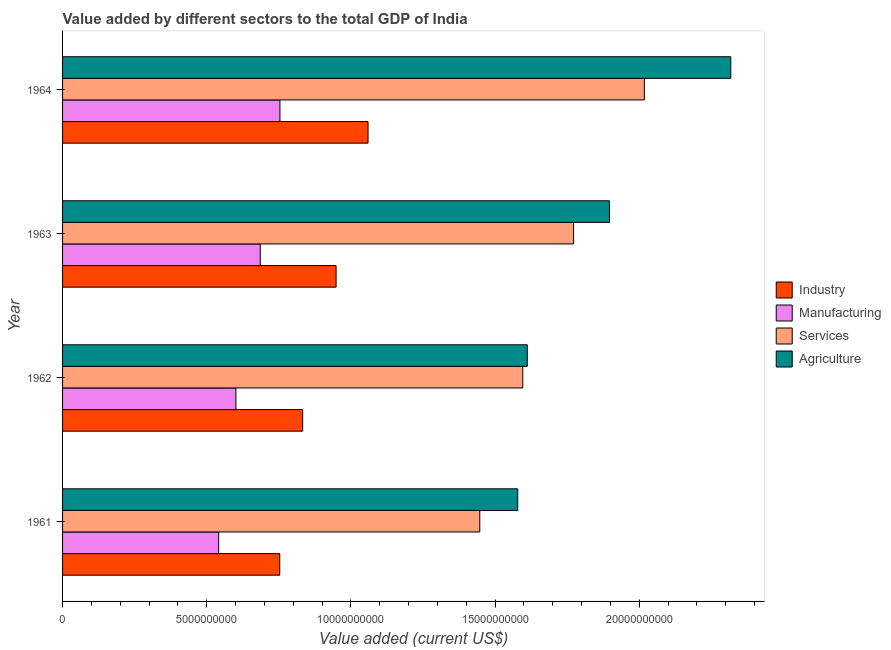How many different coloured bars are there?
Provide a short and direct response. 4. Are the number of bars on each tick of the Y-axis equal?
Offer a terse response. Yes. How many bars are there on the 4th tick from the top?
Your answer should be compact. 4. What is the label of the 3rd group of bars from the top?
Provide a short and direct response. 1962. What is the value added by industrial sector in 1964?
Your response must be concise. 1.06e+1. Across all years, what is the maximum value added by agricultural sector?
Your answer should be compact. 2.32e+1. Across all years, what is the minimum value added by agricultural sector?
Your answer should be compact. 1.58e+1. In which year was the value added by services sector maximum?
Make the answer very short. 1964. What is the total value added by manufacturing sector in the graph?
Offer a very short reply. 2.58e+1. What is the difference between the value added by manufacturing sector in 1962 and that in 1964?
Provide a succinct answer. -1.53e+09. What is the difference between the value added by agricultural sector in 1963 and the value added by services sector in 1964?
Your response must be concise. -1.21e+09. What is the average value added by manufacturing sector per year?
Provide a succinct answer. 6.45e+09. In the year 1962, what is the difference between the value added by manufacturing sector and value added by services sector?
Offer a very short reply. -9.95e+09. What is the ratio of the value added by agricultural sector in 1963 to that in 1964?
Offer a very short reply. 0.82. What is the difference between the highest and the second highest value added by agricultural sector?
Give a very brief answer. 4.21e+09. What is the difference between the highest and the lowest value added by agricultural sector?
Provide a short and direct response. 7.39e+09. Is the sum of the value added by industrial sector in 1962 and 1963 greater than the maximum value added by manufacturing sector across all years?
Your answer should be very brief. Yes. Is it the case that in every year, the sum of the value added by manufacturing sector and value added by agricultural sector is greater than the sum of value added by services sector and value added by industrial sector?
Offer a terse response. Yes. What does the 2nd bar from the top in 1962 represents?
Provide a short and direct response. Services. What does the 1st bar from the bottom in 1961 represents?
Offer a very short reply. Industry. Is it the case that in every year, the sum of the value added by industrial sector and value added by manufacturing sector is greater than the value added by services sector?
Your response must be concise. No. How many years are there in the graph?
Offer a very short reply. 4. What is the difference between two consecutive major ticks on the X-axis?
Make the answer very short. 5.00e+09. Does the graph contain grids?
Offer a very short reply. No. Where does the legend appear in the graph?
Give a very brief answer. Center right. How many legend labels are there?
Offer a terse response. 4. What is the title of the graph?
Your response must be concise. Value added by different sectors to the total GDP of India. Does "Primary schools" appear as one of the legend labels in the graph?
Your answer should be very brief. No. What is the label or title of the X-axis?
Your response must be concise. Value added (current US$). What is the label or title of the Y-axis?
Make the answer very short. Year. What is the Value added (current US$) of Industry in 1961?
Provide a succinct answer. 7.53e+09. What is the Value added (current US$) of Manufacturing in 1961?
Provide a short and direct response. 5.41e+09. What is the Value added (current US$) in Services in 1961?
Provide a succinct answer. 1.45e+1. What is the Value added (current US$) of Agriculture in 1961?
Ensure brevity in your answer.  1.58e+1. What is the Value added (current US$) of Industry in 1962?
Offer a terse response. 8.33e+09. What is the Value added (current US$) in Manufacturing in 1962?
Give a very brief answer. 6.01e+09. What is the Value added (current US$) of Services in 1962?
Give a very brief answer. 1.60e+1. What is the Value added (current US$) of Agriculture in 1962?
Offer a very short reply. 1.61e+1. What is the Value added (current US$) in Industry in 1963?
Your response must be concise. 9.49e+09. What is the Value added (current US$) in Manufacturing in 1963?
Your response must be concise. 6.85e+09. What is the Value added (current US$) in Services in 1963?
Your answer should be compact. 1.77e+1. What is the Value added (current US$) in Agriculture in 1963?
Your response must be concise. 1.90e+1. What is the Value added (current US$) of Industry in 1964?
Your answer should be very brief. 1.06e+1. What is the Value added (current US$) of Manufacturing in 1964?
Keep it short and to the point. 7.54e+09. What is the Value added (current US$) in Services in 1964?
Ensure brevity in your answer.  2.02e+1. What is the Value added (current US$) of Agriculture in 1964?
Your answer should be very brief. 2.32e+1. Across all years, what is the maximum Value added (current US$) of Industry?
Give a very brief answer. 1.06e+1. Across all years, what is the maximum Value added (current US$) in Manufacturing?
Offer a terse response. 7.54e+09. Across all years, what is the maximum Value added (current US$) in Services?
Your answer should be very brief. 2.02e+1. Across all years, what is the maximum Value added (current US$) in Agriculture?
Offer a terse response. 2.32e+1. Across all years, what is the minimum Value added (current US$) of Industry?
Your answer should be compact. 7.53e+09. Across all years, what is the minimum Value added (current US$) of Manufacturing?
Provide a succinct answer. 5.41e+09. Across all years, what is the minimum Value added (current US$) in Services?
Ensure brevity in your answer.  1.45e+1. Across all years, what is the minimum Value added (current US$) of Agriculture?
Offer a very short reply. 1.58e+1. What is the total Value added (current US$) of Industry in the graph?
Your response must be concise. 3.59e+1. What is the total Value added (current US$) in Manufacturing in the graph?
Your answer should be compact. 2.58e+1. What is the total Value added (current US$) of Services in the graph?
Offer a very short reply. 6.83e+1. What is the total Value added (current US$) in Agriculture in the graph?
Provide a short and direct response. 7.40e+1. What is the difference between the Value added (current US$) of Industry in 1961 and that in 1962?
Give a very brief answer. -7.94e+08. What is the difference between the Value added (current US$) of Manufacturing in 1961 and that in 1962?
Offer a terse response. -5.97e+08. What is the difference between the Value added (current US$) of Services in 1961 and that in 1962?
Your answer should be very brief. -1.49e+09. What is the difference between the Value added (current US$) of Agriculture in 1961 and that in 1962?
Provide a succinct answer. -3.32e+08. What is the difference between the Value added (current US$) of Industry in 1961 and that in 1963?
Offer a very short reply. -1.95e+09. What is the difference between the Value added (current US$) in Manufacturing in 1961 and that in 1963?
Provide a succinct answer. -1.44e+09. What is the difference between the Value added (current US$) of Services in 1961 and that in 1963?
Give a very brief answer. -3.25e+09. What is the difference between the Value added (current US$) in Agriculture in 1961 and that in 1963?
Make the answer very short. -3.18e+09. What is the difference between the Value added (current US$) in Industry in 1961 and that in 1964?
Provide a short and direct response. -3.06e+09. What is the difference between the Value added (current US$) of Manufacturing in 1961 and that in 1964?
Your answer should be compact. -2.12e+09. What is the difference between the Value added (current US$) of Services in 1961 and that in 1964?
Provide a short and direct response. -5.71e+09. What is the difference between the Value added (current US$) in Agriculture in 1961 and that in 1964?
Give a very brief answer. -7.39e+09. What is the difference between the Value added (current US$) of Industry in 1962 and that in 1963?
Your answer should be compact. -1.16e+09. What is the difference between the Value added (current US$) of Manufacturing in 1962 and that in 1963?
Keep it short and to the point. -8.44e+08. What is the difference between the Value added (current US$) in Services in 1962 and that in 1963?
Provide a short and direct response. -1.76e+09. What is the difference between the Value added (current US$) in Agriculture in 1962 and that in 1963?
Your response must be concise. -2.85e+09. What is the difference between the Value added (current US$) in Industry in 1962 and that in 1964?
Keep it short and to the point. -2.27e+09. What is the difference between the Value added (current US$) of Manufacturing in 1962 and that in 1964?
Provide a short and direct response. -1.53e+09. What is the difference between the Value added (current US$) of Services in 1962 and that in 1964?
Ensure brevity in your answer.  -4.22e+09. What is the difference between the Value added (current US$) of Agriculture in 1962 and that in 1964?
Make the answer very short. -7.06e+09. What is the difference between the Value added (current US$) of Industry in 1963 and that in 1964?
Give a very brief answer. -1.11e+09. What is the difference between the Value added (current US$) of Manufacturing in 1963 and that in 1964?
Your answer should be compact. -6.83e+08. What is the difference between the Value added (current US$) in Services in 1963 and that in 1964?
Your response must be concise. -2.45e+09. What is the difference between the Value added (current US$) in Agriculture in 1963 and that in 1964?
Provide a succinct answer. -4.21e+09. What is the difference between the Value added (current US$) of Industry in 1961 and the Value added (current US$) of Manufacturing in 1962?
Keep it short and to the point. 1.52e+09. What is the difference between the Value added (current US$) in Industry in 1961 and the Value added (current US$) in Services in 1962?
Make the answer very short. -8.43e+09. What is the difference between the Value added (current US$) in Industry in 1961 and the Value added (current US$) in Agriculture in 1962?
Your response must be concise. -8.58e+09. What is the difference between the Value added (current US$) of Manufacturing in 1961 and the Value added (current US$) of Services in 1962?
Make the answer very short. -1.05e+1. What is the difference between the Value added (current US$) in Manufacturing in 1961 and the Value added (current US$) in Agriculture in 1962?
Make the answer very short. -1.07e+1. What is the difference between the Value added (current US$) in Services in 1961 and the Value added (current US$) in Agriculture in 1962?
Give a very brief answer. -1.65e+09. What is the difference between the Value added (current US$) of Industry in 1961 and the Value added (current US$) of Manufacturing in 1963?
Offer a terse response. 6.76e+08. What is the difference between the Value added (current US$) of Industry in 1961 and the Value added (current US$) of Services in 1963?
Your answer should be compact. -1.02e+1. What is the difference between the Value added (current US$) of Industry in 1961 and the Value added (current US$) of Agriculture in 1963?
Provide a succinct answer. -1.14e+1. What is the difference between the Value added (current US$) of Manufacturing in 1961 and the Value added (current US$) of Services in 1963?
Make the answer very short. -1.23e+1. What is the difference between the Value added (current US$) of Manufacturing in 1961 and the Value added (current US$) of Agriculture in 1963?
Ensure brevity in your answer.  -1.36e+1. What is the difference between the Value added (current US$) in Services in 1961 and the Value added (current US$) in Agriculture in 1963?
Make the answer very short. -4.50e+09. What is the difference between the Value added (current US$) of Industry in 1961 and the Value added (current US$) of Manufacturing in 1964?
Offer a terse response. -6.79e+06. What is the difference between the Value added (current US$) of Industry in 1961 and the Value added (current US$) of Services in 1964?
Ensure brevity in your answer.  -1.26e+1. What is the difference between the Value added (current US$) in Industry in 1961 and the Value added (current US$) in Agriculture in 1964?
Keep it short and to the point. -1.56e+1. What is the difference between the Value added (current US$) in Manufacturing in 1961 and the Value added (current US$) in Services in 1964?
Offer a terse response. -1.48e+1. What is the difference between the Value added (current US$) in Manufacturing in 1961 and the Value added (current US$) in Agriculture in 1964?
Offer a very short reply. -1.78e+1. What is the difference between the Value added (current US$) of Services in 1961 and the Value added (current US$) of Agriculture in 1964?
Keep it short and to the point. -8.70e+09. What is the difference between the Value added (current US$) in Industry in 1962 and the Value added (current US$) in Manufacturing in 1963?
Make the answer very short. 1.47e+09. What is the difference between the Value added (current US$) of Industry in 1962 and the Value added (current US$) of Services in 1963?
Ensure brevity in your answer.  -9.40e+09. What is the difference between the Value added (current US$) of Industry in 1962 and the Value added (current US$) of Agriculture in 1963?
Your response must be concise. -1.06e+1. What is the difference between the Value added (current US$) in Manufacturing in 1962 and the Value added (current US$) in Services in 1963?
Your answer should be compact. -1.17e+1. What is the difference between the Value added (current US$) in Manufacturing in 1962 and the Value added (current US$) in Agriculture in 1963?
Provide a short and direct response. -1.30e+1. What is the difference between the Value added (current US$) of Services in 1962 and the Value added (current US$) of Agriculture in 1963?
Keep it short and to the point. -3.01e+09. What is the difference between the Value added (current US$) of Industry in 1962 and the Value added (current US$) of Manufacturing in 1964?
Offer a very short reply. 7.88e+08. What is the difference between the Value added (current US$) of Industry in 1962 and the Value added (current US$) of Services in 1964?
Your answer should be compact. -1.18e+1. What is the difference between the Value added (current US$) of Industry in 1962 and the Value added (current US$) of Agriculture in 1964?
Your answer should be very brief. -1.48e+1. What is the difference between the Value added (current US$) in Manufacturing in 1962 and the Value added (current US$) in Services in 1964?
Your answer should be compact. -1.42e+1. What is the difference between the Value added (current US$) in Manufacturing in 1962 and the Value added (current US$) in Agriculture in 1964?
Offer a very short reply. -1.72e+1. What is the difference between the Value added (current US$) of Services in 1962 and the Value added (current US$) of Agriculture in 1964?
Make the answer very short. -7.21e+09. What is the difference between the Value added (current US$) of Industry in 1963 and the Value added (current US$) of Manufacturing in 1964?
Offer a terse response. 1.95e+09. What is the difference between the Value added (current US$) of Industry in 1963 and the Value added (current US$) of Services in 1964?
Make the answer very short. -1.07e+1. What is the difference between the Value added (current US$) in Industry in 1963 and the Value added (current US$) in Agriculture in 1964?
Give a very brief answer. -1.37e+1. What is the difference between the Value added (current US$) of Manufacturing in 1963 and the Value added (current US$) of Services in 1964?
Give a very brief answer. -1.33e+1. What is the difference between the Value added (current US$) in Manufacturing in 1963 and the Value added (current US$) in Agriculture in 1964?
Your answer should be very brief. -1.63e+1. What is the difference between the Value added (current US$) in Services in 1963 and the Value added (current US$) in Agriculture in 1964?
Give a very brief answer. -5.45e+09. What is the average Value added (current US$) of Industry per year?
Ensure brevity in your answer.  8.98e+09. What is the average Value added (current US$) in Manufacturing per year?
Your response must be concise. 6.45e+09. What is the average Value added (current US$) in Services per year?
Your response must be concise. 1.71e+1. What is the average Value added (current US$) of Agriculture per year?
Your answer should be very brief. 1.85e+1. In the year 1961, what is the difference between the Value added (current US$) of Industry and Value added (current US$) of Manufacturing?
Provide a short and direct response. 2.12e+09. In the year 1961, what is the difference between the Value added (current US$) of Industry and Value added (current US$) of Services?
Provide a succinct answer. -6.94e+09. In the year 1961, what is the difference between the Value added (current US$) of Industry and Value added (current US$) of Agriculture?
Give a very brief answer. -8.25e+09. In the year 1961, what is the difference between the Value added (current US$) in Manufacturing and Value added (current US$) in Services?
Offer a terse response. -9.05e+09. In the year 1961, what is the difference between the Value added (current US$) of Manufacturing and Value added (current US$) of Agriculture?
Keep it short and to the point. -1.04e+1. In the year 1961, what is the difference between the Value added (current US$) of Services and Value added (current US$) of Agriculture?
Your answer should be compact. -1.32e+09. In the year 1962, what is the difference between the Value added (current US$) of Industry and Value added (current US$) of Manufacturing?
Your answer should be compact. 2.31e+09. In the year 1962, what is the difference between the Value added (current US$) in Industry and Value added (current US$) in Services?
Your response must be concise. -7.63e+09. In the year 1962, what is the difference between the Value added (current US$) of Industry and Value added (current US$) of Agriculture?
Keep it short and to the point. -7.79e+09. In the year 1962, what is the difference between the Value added (current US$) in Manufacturing and Value added (current US$) in Services?
Your answer should be very brief. -9.95e+09. In the year 1962, what is the difference between the Value added (current US$) of Manufacturing and Value added (current US$) of Agriculture?
Your answer should be very brief. -1.01e+1. In the year 1962, what is the difference between the Value added (current US$) of Services and Value added (current US$) of Agriculture?
Your answer should be very brief. -1.56e+08. In the year 1963, what is the difference between the Value added (current US$) of Industry and Value added (current US$) of Manufacturing?
Your answer should be very brief. 2.63e+09. In the year 1963, what is the difference between the Value added (current US$) of Industry and Value added (current US$) of Services?
Your answer should be very brief. -8.24e+09. In the year 1963, what is the difference between the Value added (current US$) of Industry and Value added (current US$) of Agriculture?
Provide a succinct answer. -9.48e+09. In the year 1963, what is the difference between the Value added (current US$) of Manufacturing and Value added (current US$) of Services?
Your response must be concise. -1.09e+1. In the year 1963, what is the difference between the Value added (current US$) in Manufacturing and Value added (current US$) in Agriculture?
Offer a very short reply. -1.21e+1. In the year 1963, what is the difference between the Value added (current US$) in Services and Value added (current US$) in Agriculture?
Your answer should be compact. -1.24e+09. In the year 1964, what is the difference between the Value added (current US$) in Industry and Value added (current US$) in Manufacturing?
Offer a very short reply. 3.06e+09. In the year 1964, what is the difference between the Value added (current US$) of Industry and Value added (current US$) of Services?
Offer a very short reply. -9.58e+09. In the year 1964, what is the difference between the Value added (current US$) of Industry and Value added (current US$) of Agriculture?
Provide a short and direct response. -1.26e+1. In the year 1964, what is the difference between the Value added (current US$) in Manufacturing and Value added (current US$) in Services?
Your answer should be very brief. -1.26e+1. In the year 1964, what is the difference between the Value added (current US$) in Manufacturing and Value added (current US$) in Agriculture?
Provide a succinct answer. -1.56e+1. In the year 1964, what is the difference between the Value added (current US$) of Services and Value added (current US$) of Agriculture?
Your answer should be compact. -3.00e+09. What is the ratio of the Value added (current US$) in Industry in 1961 to that in 1962?
Your answer should be very brief. 0.9. What is the ratio of the Value added (current US$) in Manufacturing in 1961 to that in 1962?
Provide a succinct answer. 0.9. What is the ratio of the Value added (current US$) in Services in 1961 to that in 1962?
Make the answer very short. 0.91. What is the ratio of the Value added (current US$) of Agriculture in 1961 to that in 1962?
Offer a terse response. 0.98. What is the ratio of the Value added (current US$) in Industry in 1961 to that in 1963?
Your answer should be very brief. 0.79. What is the ratio of the Value added (current US$) of Manufacturing in 1961 to that in 1963?
Your answer should be compact. 0.79. What is the ratio of the Value added (current US$) of Services in 1961 to that in 1963?
Ensure brevity in your answer.  0.82. What is the ratio of the Value added (current US$) in Agriculture in 1961 to that in 1963?
Your response must be concise. 0.83. What is the ratio of the Value added (current US$) in Industry in 1961 to that in 1964?
Your response must be concise. 0.71. What is the ratio of the Value added (current US$) of Manufacturing in 1961 to that in 1964?
Provide a short and direct response. 0.72. What is the ratio of the Value added (current US$) in Services in 1961 to that in 1964?
Offer a very short reply. 0.72. What is the ratio of the Value added (current US$) in Agriculture in 1961 to that in 1964?
Offer a very short reply. 0.68. What is the ratio of the Value added (current US$) in Industry in 1962 to that in 1963?
Provide a succinct answer. 0.88. What is the ratio of the Value added (current US$) in Manufacturing in 1962 to that in 1963?
Keep it short and to the point. 0.88. What is the ratio of the Value added (current US$) in Services in 1962 to that in 1963?
Your answer should be very brief. 0.9. What is the ratio of the Value added (current US$) in Agriculture in 1962 to that in 1963?
Offer a terse response. 0.85. What is the ratio of the Value added (current US$) in Industry in 1962 to that in 1964?
Your response must be concise. 0.79. What is the ratio of the Value added (current US$) in Manufacturing in 1962 to that in 1964?
Your answer should be very brief. 0.8. What is the ratio of the Value added (current US$) in Services in 1962 to that in 1964?
Provide a short and direct response. 0.79. What is the ratio of the Value added (current US$) in Agriculture in 1962 to that in 1964?
Offer a very short reply. 0.7. What is the ratio of the Value added (current US$) in Industry in 1963 to that in 1964?
Your response must be concise. 0.9. What is the ratio of the Value added (current US$) of Manufacturing in 1963 to that in 1964?
Keep it short and to the point. 0.91. What is the ratio of the Value added (current US$) of Services in 1963 to that in 1964?
Offer a terse response. 0.88. What is the ratio of the Value added (current US$) in Agriculture in 1963 to that in 1964?
Provide a succinct answer. 0.82. What is the difference between the highest and the second highest Value added (current US$) of Industry?
Offer a very short reply. 1.11e+09. What is the difference between the highest and the second highest Value added (current US$) in Manufacturing?
Provide a succinct answer. 6.83e+08. What is the difference between the highest and the second highest Value added (current US$) in Services?
Give a very brief answer. 2.45e+09. What is the difference between the highest and the second highest Value added (current US$) of Agriculture?
Provide a succinct answer. 4.21e+09. What is the difference between the highest and the lowest Value added (current US$) of Industry?
Provide a succinct answer. 3.06e+09. What is the difference between the highest and the lowest Value added (current US$) in Manufacturing?
Give a very brief answer. 2.12e+09. What is the difference between the highest and the lowest Value added (current US$) in Services?
Provide a short and direct response. 5.71e+09. What is the difference between the highest and the lowest Value added (current US$) of Agriculture?
Provide a succinct answer. 7.39e+09. 